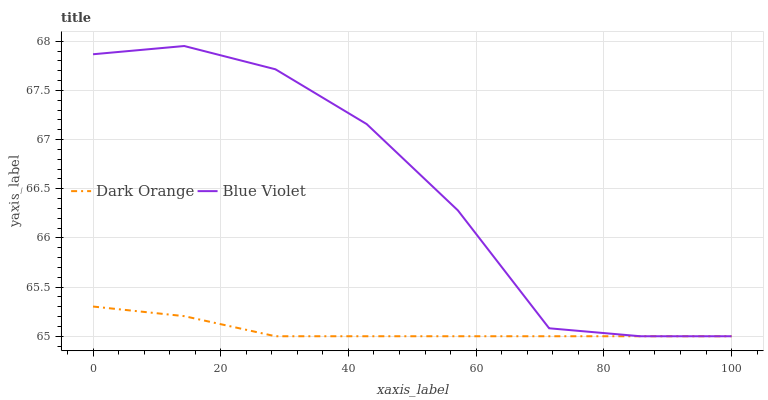Does Dark Orange have the minimum area under the curve?
Answer yes or no. Yes. Does Blue Violet have the maximum area under the curve?
Answer yes or no. Yes. Does Blue Violet have the minimum area under the curve?
Answer yes or no. No. Is Dark Orange the smoothest?
Answer yes or no. Yes. Is Blue Violet the roughest?
Answer yes or no. Yes. Is Blue Violet the smoothest?
Answer yes or no. No. Does Dark Orange have the lowest value?
Answer yes or no. Yes. Does Blue Violet have the highest value?
Answer yes or no. Yes. Does Blue Violet intersect Dark Orange?
Answer yes or no. Yes. Is Blue Violet less than Dark Orange?
Answer yes or no. No. Is Blue Violet greater than Dark Orange?
Answer yes or no. No. 